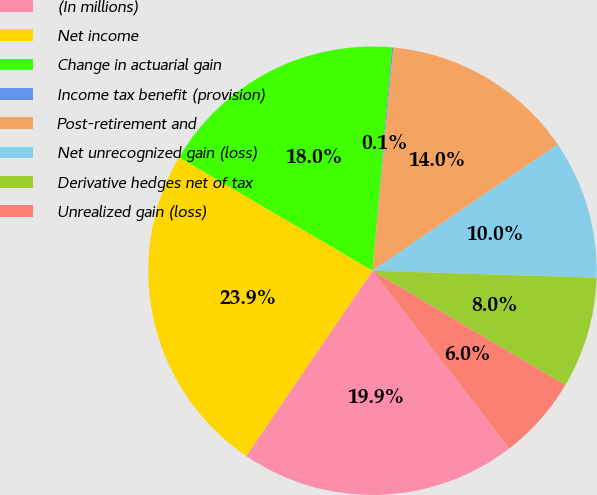<chart> <loc_0><loc_0><loc_500><loc_500><pie_chart><fcel>(In millions)<fcel>Net income<fcel>Change in actuarial gain<fcel>Income tax benefit (provision)<fcel>Post-retirement and<fcel>Net unrecognized gain (loss)<fcel>Derivative hedges net of tax<fcel>Unrealized gain (loss)<nl><fcel>19.95%<fcel>23.92%<fcel>17.96%<fcel>0.09%<fcel>13.99%<fcel>10.02%<fcel>8.03%<fcel>6.05%<nl></chart> 